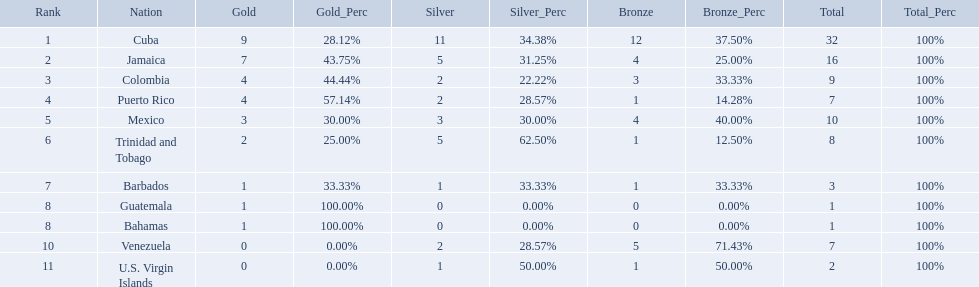What teams had four gold medals? Colombia, Puerto Rico. Of these two, which team only had one bronze medal? Puerto Rico. What nation has won at least 4 gold medals? Cuba, Jamaica, Colombia, Puerto Rico. Of these countries who has won the least amount of bronze medals? Puerto Rico. 